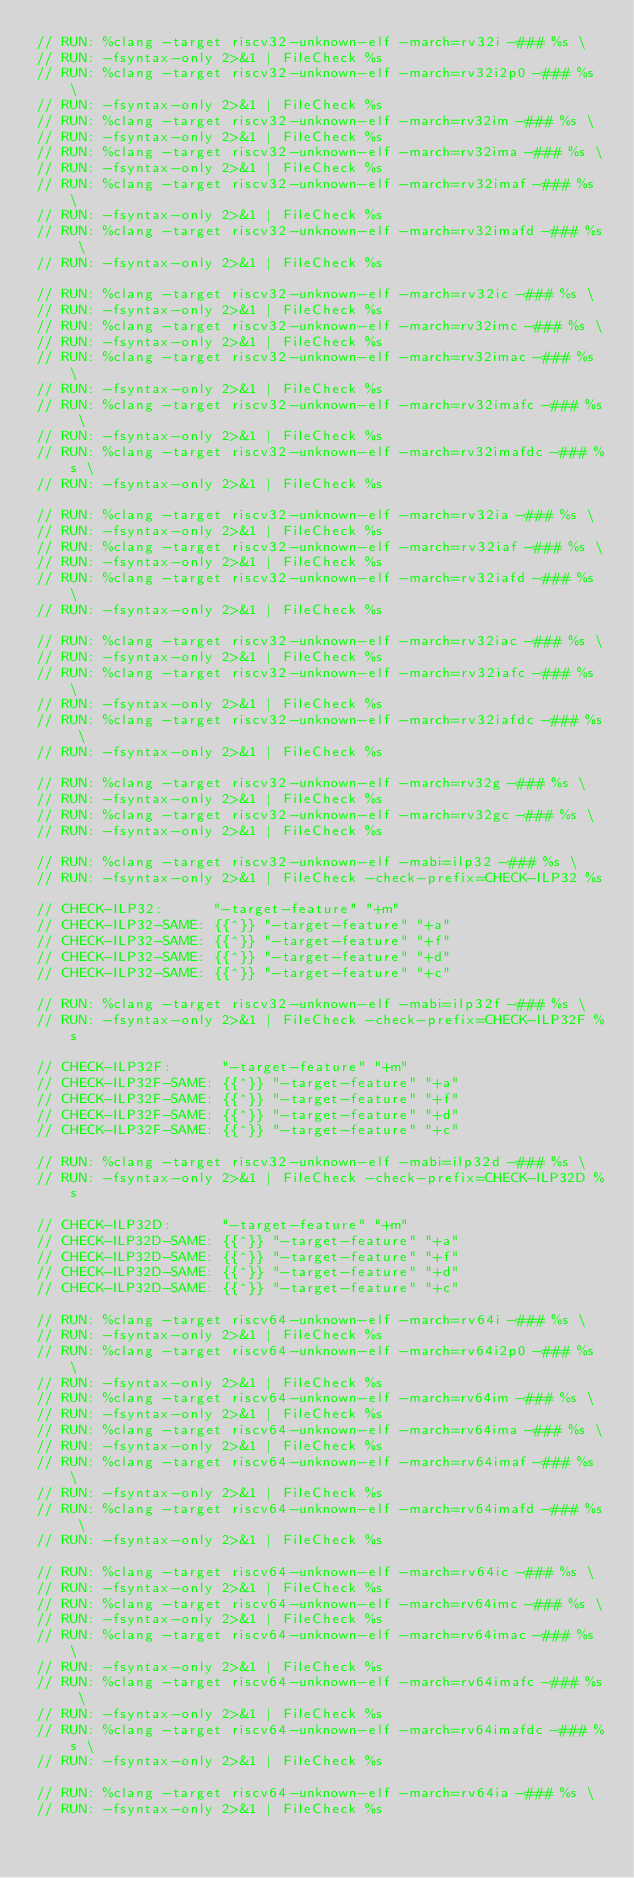Convert code to text. <code><loc_0><loc_0><loc_500><loc_500><_C_>// RUN: %clang -target riscv32-unknown-elf -march=rv32i -### %s \
// RUN: -fsyntax-only 2>&1 | FileCheck %s
// RUN: %clang -target riscv32-unknown-elf -march=rv32i2p0 -### %s \
// RUN: -fsyntax-only 2>&1 | FileCheck %s
// RUN: %clang -target riscv32-unknown-elf -march=rv32im -### %s \
// RUN: -fsyntax-only 2>&1 | FileCheck %s
// RUN: %clang -target riscv32-unknown-elf -march=rv32ima -### %s \
// RUN: -fsyntax-only 2>&1 | FileCheck %s
// RUN: %clang -target riscv32-unknown-elf -march=rv32imaf -### %s \
// RUN: -fsyntax-only 2>&1 | FileCheck %s
// RUN: %clang -target riscv32-unknown-elf -march=rv32imafd -### %s \
// RUN: -fsyntax-only 2>&1 | FileCheck %s

// RUN: %clang -target riscv32-unknown-elf -march=rv32ic -### %s \
// RUN: -fsyntax-only 2>&1 | FileCheck %s
// RUN: %clang -target riscv32-unknown-elf -march=rv32imc -### %s \
// RUN: -fsyntax-only 2>&1 | FileCheck %s
// RUN: %clang -target riscv32-unknown-elf -march=rv32imac -### %s \
// RUN: -fsyntax-only 2>&1 | FileCheck %s
// RUN: %clang -target riscv32-unknown-elf -march=rv32imafc -### %s \
// RUN: -fsyntax-only 2>&1 | FileCheck %s
// RUN: %clang -target riscv32-unknown-elf -march=rv32imafdc -### %s \
// RUN: -fsyntax-only 2>&1 | FileCheck %s

// RUN: %clang -target riscv32-unknown-elf -march=rv32ia -### %s \
// RUN: -fsyntax-only 2>&1 | FileCheck %s
// RUN: %clang -target riscv32-unknown-elf -march=rv32iaf -### %s \
// RUN: -fsyntax-only 2>&1 | FileCheck %s
// RUN: %clang -target riscv32-unknown-elf -march=rv32iafd -### %s \
// RUN: -fsyntax-only 2>&1 | FileCheck %s

// RUN: %clang -target riscv32-unknown-elf -march=rv32iac -### %s \
// RUN: -fsyntax-only 2>&1 | FileCheck %s
// RUN: %clang -target riscv32-unknown-elf -march=rv32iafc -### %s \
// RUN: -fsyntax-only 2>&1 | FileCheck %s
// RUN: %clang -target riscv32-unknown-elf -march=rv32iafdc -### %s \
// RUN: -fsyntax-only 2>&1 | FileCheck %s

// RUN: %clang -target riscv32-unknown-elf -march=rv32g -### %s \
// RUN: -fsyntax-only 2>&1 | FileCheck %s
// RUN: %clang -target riscv32-unknown-elf -march=rv32gc -### %s \
// RUN: -fsyntax-only 2>&1 | FileCheck %s

// RUN: %clang -target riscv32-unknown-elf -mabi=ilp32 -### %s \
// RUN: -fsyntax-only 2>&1 | FileCheck -check-prefix=CHECK-ILP32 %s

// CHECK-ILP32:      "-target-feature" "+m"
// CHECK-ILP32-SAME: {{^}} "-target-feature" "+a"
// CHECK-ILP32-SAME: {{^}} "-target-feature" "+f"
// CHECK-ILP32-SAME: {{^}} "-target-feature" "+d"
// CHECK-ILP32-SAME: {{^}} "-target-feature" "+c"

// RUN: %clang -target riscv32-unknown-elf -mabi=ilp32f -### %s \
// RUN: -fsyntax-only 2>&1 | FileCheck -check-prefix=CHECK-ILP32F %s

// CHECK-ILP32F:      "-target-feature" "+m"
// CHECK-ILP32F-SAME: {{^}} "-target-feature" "+a"
// CHECK-ILP32F-SAME: {{^}} "-target-feature" "+f"
// CHECK-ILP32F-SAME: {{^}} "-target-feature" "+d"
// CHECK-ILP32F-SAME: {{^}} "-target-feature" "+c"

// RUN: %clang -target riscv32-unknown-elf -mabi=ilp32d -### %s \
// RUN: -fsyntax-only 2>&1 | FileCheck -check-prefix=CHECK-ILP32D %s

// CHECK-ILP32D:      "-target-feature" "+m"
// CHECK-ILP32D-SAME: {{^}} "-target-feature" "+a"
// CHECK-ILP32D-SAME: {{^}} "-target-feature" "+f"
// CHECK-ILP32D-SAME: {{^}} "-target-feature" "+d"
// CHECK-ILP32D-SAME: {{^}} "-target-feature" "+c"

// RUN: %clang -target riscv64-unknown-elf -march=rv64i -### %s \
// RUN: -fsyntax-only 2>&1 | FileCheck %s
// RUN: %clang -target riscv64-unknown-elf -march=rv64i2p0 -### %s \
// RUN: -fsyntax-only 2>&1 | FileCheck %s
// RUN: %clang -target riscv64-unknown-elf -march=rv64im -### %s \
// RUN: -fsyntax-only 2>&1 | FileCheck %s
// RUN: %clang -target riscv64-unknown-elf -march=rv64ima -### %s \
// RUN: -fsyntax-only 2>&1 | FileCheck %s
// RUN: %clang -target riscv64-unknown-elf -march=rv64imaf -### %s \
// RUN: -fsyntax-only 2>&1 | FileCheck %s
// RUN: %clang -target riscv64-unknown-elf -march=rv64imafd -### %s \
// RUN: -fsyntax-only 2>&1 | FileCheck %s

// RUN: %clang -target riscv64-unknown-elf -march=rv64ic -### %s \
// RUN: -fsyntax-only 2>&1 | FileCheck %s
// RUN: %clang -target riscv64-unknown-elf -march=rv64imc -### %s \
// RUN: -fsyntax-only 2>&1 | FileCheck %s
// RUN: %clang -target riscv64-unknown-elf -march=rv64imac -### %s \
// RUN: -fsyntax-only 2>&1 | FileCheck %s
// RUN: %clang -target riscv64-unknown-elf -march=rv64imafc -### %s \
// RUN: -fsyntax-only 2>&1 | FileCheck %s
// RUN: %clang -target riscv64-unknown-elf -march=rv64imafdc -### %s \
// RUN: -fsyntax-only 2>&1 | FileCheck %s

// RUN: %clang -target riscv64-unknown-elf -march=rv64ia -### %s \
// RUN: -fsyntax-only 2>&1 | FileCheck %s</code> 